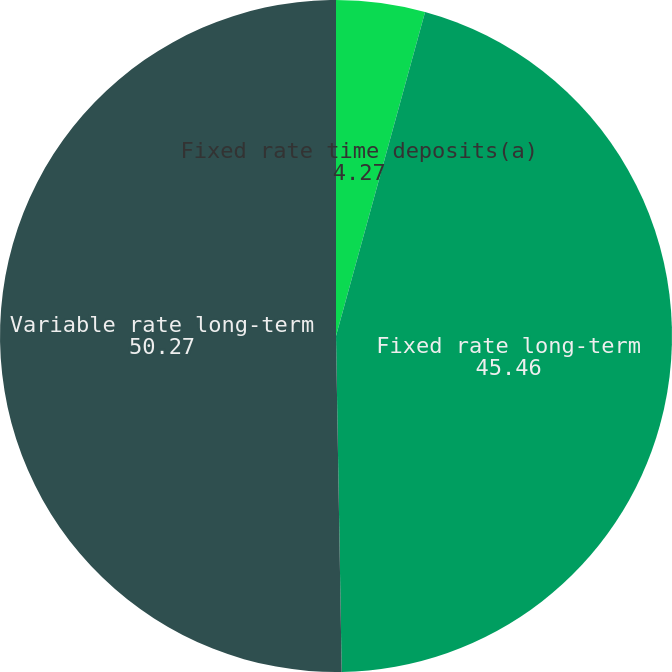Convert chart. <chart><loc_0><loc_0><loc_500><loc_500><pie_chart><fcel>Fixed rate time deposits(a)<fcel>Fixed rate long-term<fcel>Variable rate long-term<nl><fcel>4.27%<fcel>45.46%<fcel>50.27%<nl></chart> 